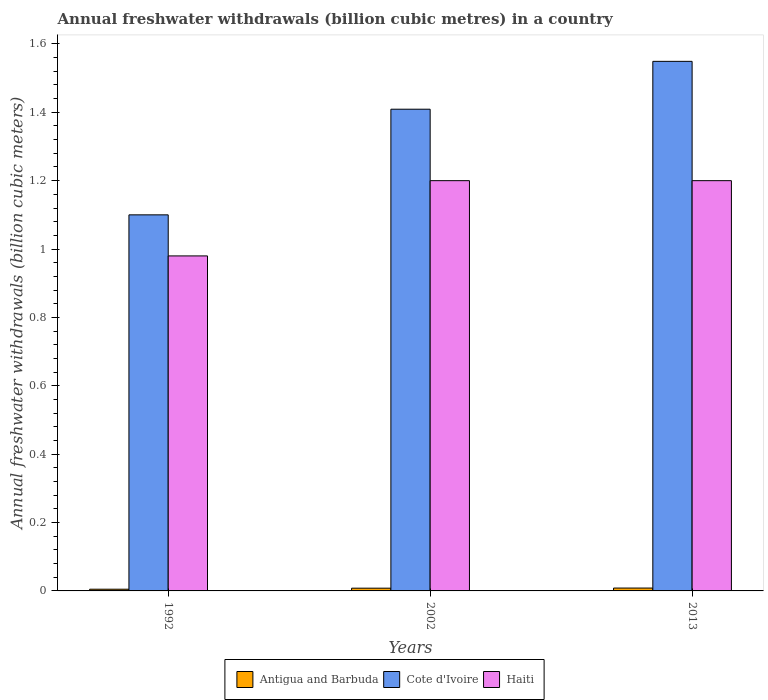How many different coloured bars are there?
Provide a succinct answer. 3. Are the number of bars on each tick of the X-axis equal?
Your response must be concise. Yes. How many bars are there on the 2nd tick from the right?
Provide a short and direct response. 3. What is the annual freshwater withdrawals in Cote d'Ivoire in 2002?
Provide a short and direct response. 1.41. Across all years, what is the maximum annual freshwater withdrawals in Cote d'Ivoire?
Make the answer very short. 1.55. Across all years, what is the minimum annual freshwater withdrawals in Haiti?
Offer a terse response. 0.98. In which year was the annual freshwater withdrawals in Haiti maximum?
Your answer should be compact. 2002. What is the total annual freshwater withdrawals in Antigua and Barbuda in the graph?
Offer a terse response. 0.02. What is the difference between the annual freshwater withdrawals in Haiti in 1992 and that in 2002?
Provide a succinct answer. -0.22. What is the difference between the annual freshwater withdrawals in Antigua and Barbuda in 1992 and the annual freshwater withdrawals in Haiti in 2013?
Provide a short and direct response. -1.2. What is the average annual freshwater withdrawals in Cote d'Ivoire per year?
Ensure brevity in your answer.  1.35. In the year 2002, what is the difference between the annual freshwater withdrawals in Antigua and Barbuda and annual freshwater withdrawals in Cote d'Ivoire?
Provide a short and direct response. -1.4. What is the ratio of the annual freshwater withdrawals in Cote d'Ivoire in 1992 to that in 2013?
Ensure brevity in your answer.  0.71. Is the annual freshwater withdrawals in Haiti in 1992 less than that in 2013?
Your answer should be compact. Yes. What is the difference between the highest and the lowest annual freshwater withdrawals in Haiti?
Offer a very short reply. 0.22. In how many years, is the annual freshwater withdrawals in Haiti greater than the average annual freshwater withdrawals in Haiti taken over all years?
Give a very brief answer. 2. Is the sum of the annual freshwater withdrawals in Cote d'Ivoire in 1992 and 2013 greater than the maximum annual freshwater withdrawals in Haiti across all years?
Keep it short and to the point. Yes. What does the 2nd bar from the left in 2013 represents?
Provide a succinct answer. Cote d'Ivoire. What does the 1st bar from the right in 2013 represents?
Ensure brevity in your answer.  Haiti. How many years are there in the graph?
Your answer should be very brief. 3. Where does the legend appear in the graph?
Provide a short and direct response. Bottom center. How many legend labels are there?
Offer a very short reply. 3. How are the legend labels stacked?
Your answer should be very brief. Horizontal. What is the title of the graph?
Give a very brief answer. Annual freshwater withdrawals (billion cubic metres) in a country. What is the label or title of the X-axis?
Your response must be concise. Years. What is the label or title of the Y-axis?
Your answer should be compact. Annual freshwater withdrawals (billion cubic meters). What is the Annual freshwater withdrawals (billion cubic meters) of Antigua and Barbuda in 1992?
Your response must be concise. 0.01. What is the Annual freshwater withdrawals (billion cubic meters) in Cote d'Ivoire in 1992?
Provide a short and direct response. 1.1. What is the Annual freshwater withdrawals (billion cubic meters) of Haiti in 1992?
Your response must be concise. 0.98. What is the Annual freshwater withdrawals (billion cubic meters) in Antigua and Barbuda in 2002?
Keep it short and to the point. 0.01. What is the Annual freshwater withdrawals (billion cubic meters) in Cote d'Ivoire in 2002?
Offer a terse response. 1.41. What is the Annual freshwater withdrawals (billion cubic meters) in Antigua and Barbuda in 2013?
Your answer should be compact. 0.01. What is the Annual freshwater withdrawals (billion cubic meters) in Cote d'Ivoire in 2013?
Ensure brevity in your answer.  1.55. What is the Annual freshwater withdrawals (billion cubic meters) of Haiti in 2013?
Offer a very short reply. 1.2. Across all years, what is the maximum Annual freshwater withdrawals (billion cubic meters) in Antigua and Barbuda?
Give a very brief answer. 0.01. Across all years, what is the maximum Annual freshwater withdrawals (billion cubic meters) in Cote d'Ivoire?
Your response must be concise. 1.55. Across all years, what is the minimum Annual freshwater withdrawals (billion cubic meters) in Antigua and Barbuda?
Provide a succinct answer. 0.01. Across all years, what is the minimum Annual freshwater withdrawals (billion cubic meters) of Haiti?
Your answer should be compact. 0.98. What is the total Annual freshwater withdrawals (billion cubic meters) of Antigua and Barbuda in the graph?
Make the answer very short. 0.02. What is the total Annual freshwater withdrawals (billion cubic meters) of Cote d'Ivoire in the graph?
Provide a succinct answer. 4.06. What is the total Annual freshwater withdrawals (billion cubic meters) in Haiti in the graph?
Provide a short and direct response. 3.38. What is the difference between the Annual freshwater withdrawals (billion cubic meters) in Antigua and Barbuda in 1992 and that in 2002?
Offer a terse response. -0. What is the difference between the Annual freshwater withdrawals (billion cubic meters) of Cote d'Ivoire in 1992 and that in 2002?
Offer a very short reply. -0.31. What is the difference between the Annual freshwater withdrawals (billion cubic meters) in Haiti in 1992 and that in 2002?
Provide a short and direct response. -0.22. What is the difference between the Annual freshwater withdrawals (billion cubic meters) in Antigua and Barbuda in 1992 and that in 2013?
Provide a succinct answer. -0. What is the difference between the Annual freshwater withdrawals (billion cubic meters) of Cote d'Ivoire in 1992 and that in 2013?
Offer a terse response. -0.45. What is the difference between the Annual freshwater withdrawals (billion cubic meters) of Haiti in 1992 and that in 2013?
Offer a terse response. -0.22. What is the difference between the Annual freshwater withdrawals (billion cubic meters) in Antigua and Barbuda in 2002 and that in 2013?
Your answer should be compact. -0. What is the difference between the Annual freshwater withdrawals (billion cubic meters) in Cote d'Ivoire in 2002 and that in 2013?
Provide a short and direct response. -0.14. What is the difference between the Annual freshwater withdrawals (billion cubic meters) in Antigua and Barbuda in 1992 and the Annual freshwater withdrawals (billion cubic meters) in Cote d'Ivoire in 2002?
Offer a terse response. -1.4. What is the difference between the Annual freshwater withdrawals (billion cubic meters) in Antigua and Barbuda in 1992 and the Annual freshwater withdrawals (billion cubic meters) in Haiti in 2002?
Provide a succinct answer. -1.2. What is the difference between the Annual freshwater withdrawals (billion cubic meters) in Antigua and Barbuda in 1992 and the Annual freshwater withdrawals (billion cubic meters) in Cote d'Ivoire in 2013?
Ensure brevity in your answer.  -1.54. What is the difference between the Annual freshwater withdrawals (billion cubic meters) of Antigua and Barbuda in 1992 and the Annual freshwater withdrawals (billion cubic meters) of Haiti in 2013?
Keep it short and to the point. -1.2. What is the difference between the Annual freshwater withdrawals (billion cubic meters) of Antigua and Barbuda in 2002 and the Annual freshwater withdrawals (billion cubic meters) of Cote d'Ivoire in 2013?
Provide a succinct answer. -1.54. What is the difference between the Annual freshwater withdrawals (billion cubic meters) in Antigua and Barbuda in 2002 and the Annual freshwater withdrawals (billion cubic meters) in Haiti in 2013?
Keep it short and to the point. -1.19. What is the difference between the Annual freshwater withdrawals (billion cubic meters) of Cote d'Ivoire in 2002 and the Annual freshwater withdrawals (billion cubic meters) of Haiti in 2013?
Your answer should be compact. 0.21. What is the average Annual freshwater withdrawals (billion cubic meters) in Antigua and Barbuda per year?
Make the answer very short. 0.01. What is the average Annual freshwater withdrawals (billion cubic meters) in Cote d'Ivoire per year?
Ensure brevity in your answer.  1.35. What is the average Annual freshwater withdrawals (billion cubic meters) of Haiti per year?
Make the answer very short. 1.13. In the year 1992, what is the difference between the Annual freshwater withdrawals (billion cubic meters) of Antigua and Barbuda and Annual freshwater withdrawals (billion cubic meters) of Cote d'Ivoire?
Provide a short and direct response. -1.09. In the year 1992, what is the difference between the Annual freshwater withdrawals (billion cubic meters) in Antigua and Barbuda and Annual freshwater withdrawals (billion cubic meters) in Haiti?
Offer a terse response. -0.97. In the year 1992, what is the difference between the Annual freshwater withdrawals (billion cubic meters) in Cote d'Ivoire and Annual freshwater withdrawals (billion cubic meters) in Haiti?
Your answer should be very brief. 0.12. In the year 2002, what is the difference between the Annual freshwater withdrawals (billion cubic meters) of Antigua and Barbuda and Annual freshwater withdrawals (billion cubic meters) of Cote d'Ivoire?
Offer a terse response. -1.4. In the year 2002, what is the difference between the Annual freshwater withdrawals (billion cubic meters) in Antigua and Barbuda and Annual freshwater withdrawals (billion cubic meters) in Haiti?
Give a very brief answer. -1.19. In the year 2002, what is the difference between the Annual freshwater withdrawals (billion cubic meters) of Cote d'Ivoire and Annual freshwater withdrawals (billion cubic meters) of Haiti?
Your response must be concise. 0.21. In the year 2013, what is the difference between the Annual freshwater withdrawals (billion cubic meters) in Antigua and Barbuda and Annual freshwater withdrawals (billion cubic meters) in Cote d'Ivoire?
Offer a terse response. -1.54. In the year 2013, what is the difference between the Annual freshwater withdrawals (billion cubic meters) of Antigua and Barbuda and Annual freshwater withdrawals (billion cubic meters) of Haiti?
Keep it short and to the point. -1.19. In the year 2013, what is the difference between the Annual freshwater withdrawals (billion cubic meters) in Cote d'Ivoire and Annual freshwater withdrawals (billion cubic meters) in Haiti?
Provide a short and direct response. 0.35. What is the ratio of the Annual freshwater withdrawals (billion cubic meters) in Cote d'Ivoire in 1992 to that in 2002?
Your answer should be compact. 0.78. What is the ratio of the Annual freshwater withdrawals (billion cubic meters) of Haiti in 1992 to that in 2002?
Keep it short and to the point. 0.82. What is the ratio of the Annual freshwater withdrawals (billion cubic meters) of Antigua and Barbuda in 1992 to that in 2013?
Provide a short and direct response. 0.6. What is the ratio of the Annual freshwater withdrawals (billion cubic meters) in Cote d'Ivoire in 1992 to that in 2013?
Your response must be concise. 0.71. What is the ratio of the Annual freshwater withdrawals (billion cubic meters) in Haiti in 1992 to that in 2013?
Provide a short and direct response. 0.82. What is the ratio of the Annual freshwater withdrawals (billion cubic meters) in Antigua and Barbuda in 2002 to that in 2013?
Keep it short and to the point. 0.95. What is the ratio of the Annual freshwater withdrawals (billion cubic meters) in Cote d'Ivoire in 2002 to that in 2013?
Provide a succinct answer. 0.91. What is the ratio of the Annual freshwater withdrawals (billion cubic meters) of Haiti in 2002 to that in 2013?
Keep it short and to the point. 1. What is the difference between the highest and the second highest Annual freshwater withdrawals (billion cubic meters) in Antigua and Barbuda?
Make the answer very short. 0. What is the difference between the highest and the second highest Annual freshwater withdrawals (billion cubic meters) in Cote d'Ivoire?
Provide a succinct answer. 0.14. What is the difference between the highest and the second highest Annual freshwater withdrawals (billion cubic meters) in Haiti?
Offer a terse response. 0. What is the difference between the highest and the lowest Annual freshwater withdrawals (billion cubic meters) in Antigua and Barbuda?
Ensure brevity in your answer.  0. What is the difference between the highest and the lowest Annual freshwater withdrawals (billion cubic meters) of Cote d'Ivoire?
Keep it short and to the point. 0.45. What is the difference between the highest and the lowest Annual freshwater withdrawals (billion cubic meters) in Haiti?
Provide a succinct answer. 0.22. 